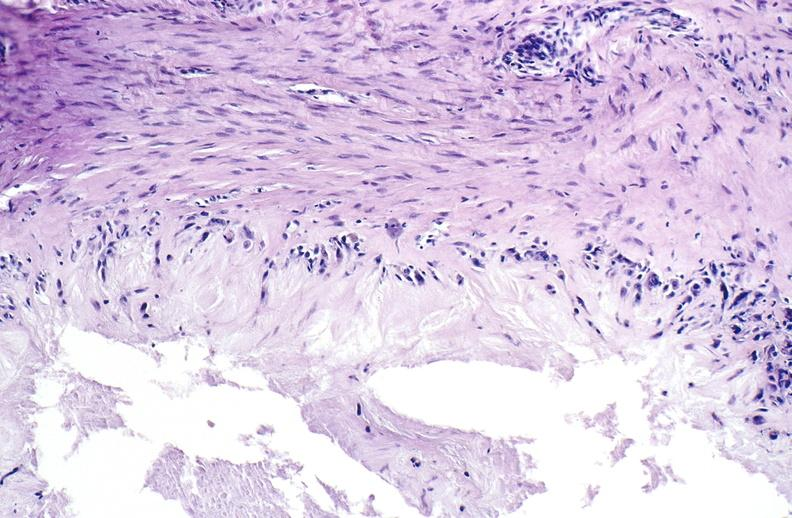what does this image show?
Answer the question using a single word or phrase. Gout 